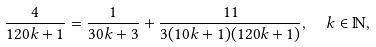Convert formula to latex. <formula><loc_0><loc_0><loc_500><loc_500>\frac { 4 } { 1 2 0 k + 1 } = \frac { 1 } { 3 0 k + 3 } + \frac { 1 1 } { 3 ( 1 0 k + 1 ) ( 1 2 0 k + 1 ) } , \ \ k \in \mathbb { N } ,</formula> 